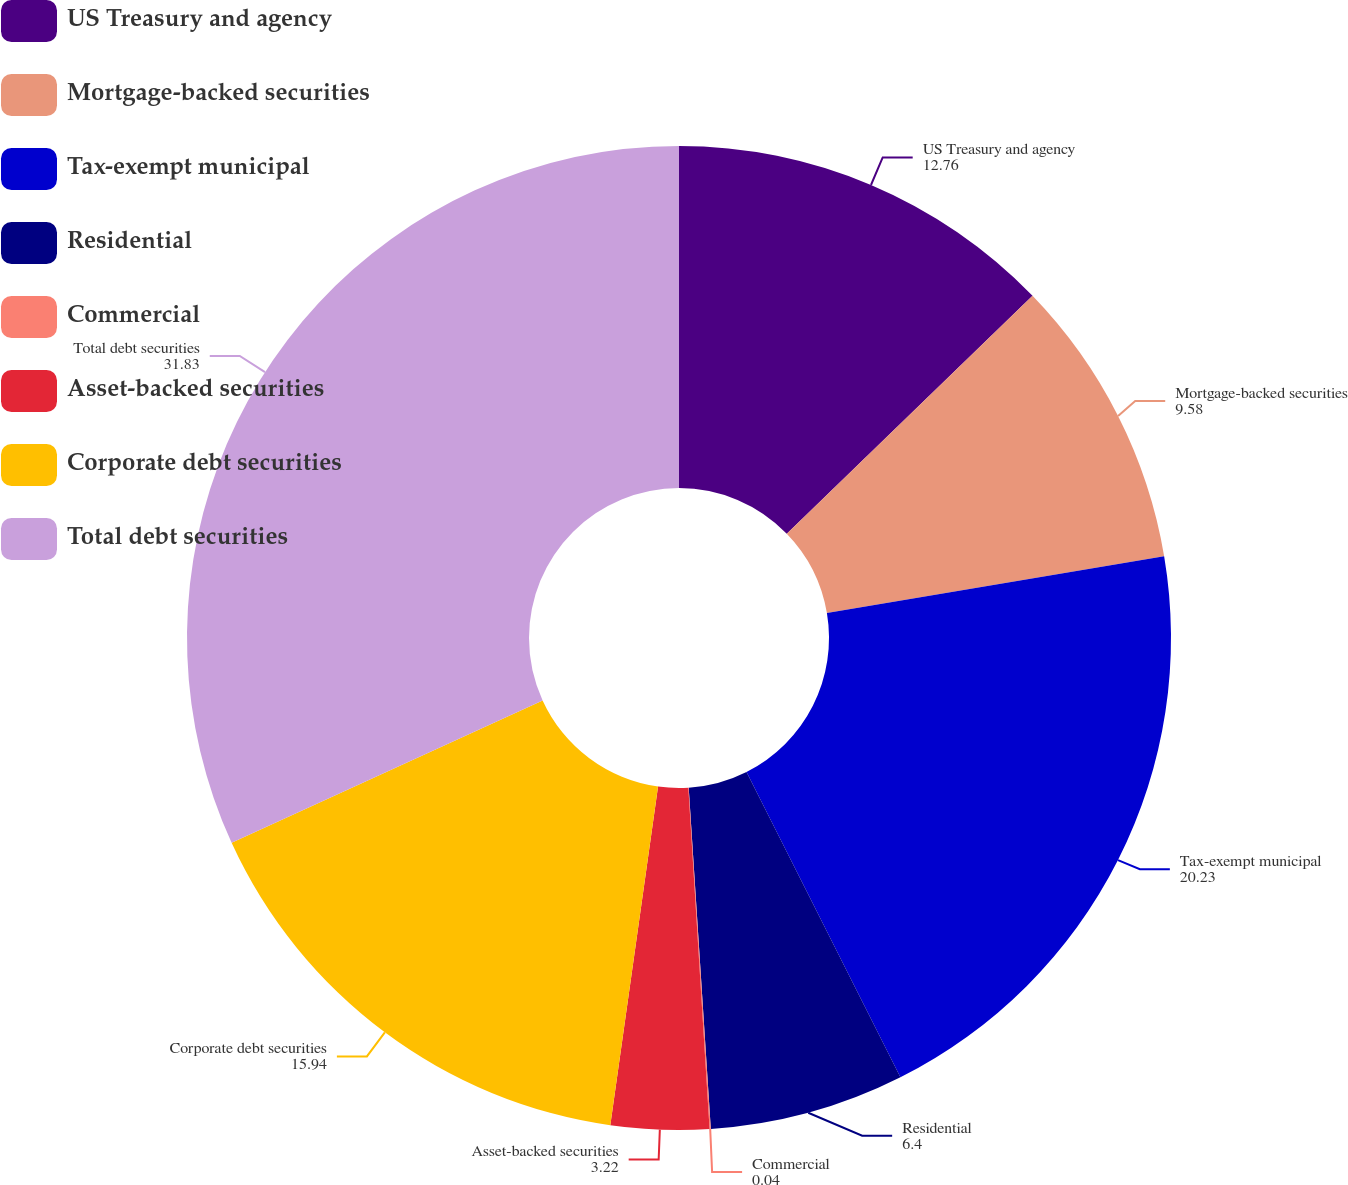<chart> <loc_0><loc_0><loc_500><loc_500><pie_chart><fcel>US Treasury and agency<fcel>Mortgage-backed securities<fcel>Tax-exempt municipal<fcel>Residential<fcel>Commercial<fcel>Asset-backed securities<fcel>Corporate debt securities<fcel>Total debt securities<nl><fcel>12.76%<fcel>9.58%<fcel>20.23%<fcel>6.4%<fcel>0.04%<fcel>3.22%<fcel>15.94%<fcel>31.83%<nl></chart> 